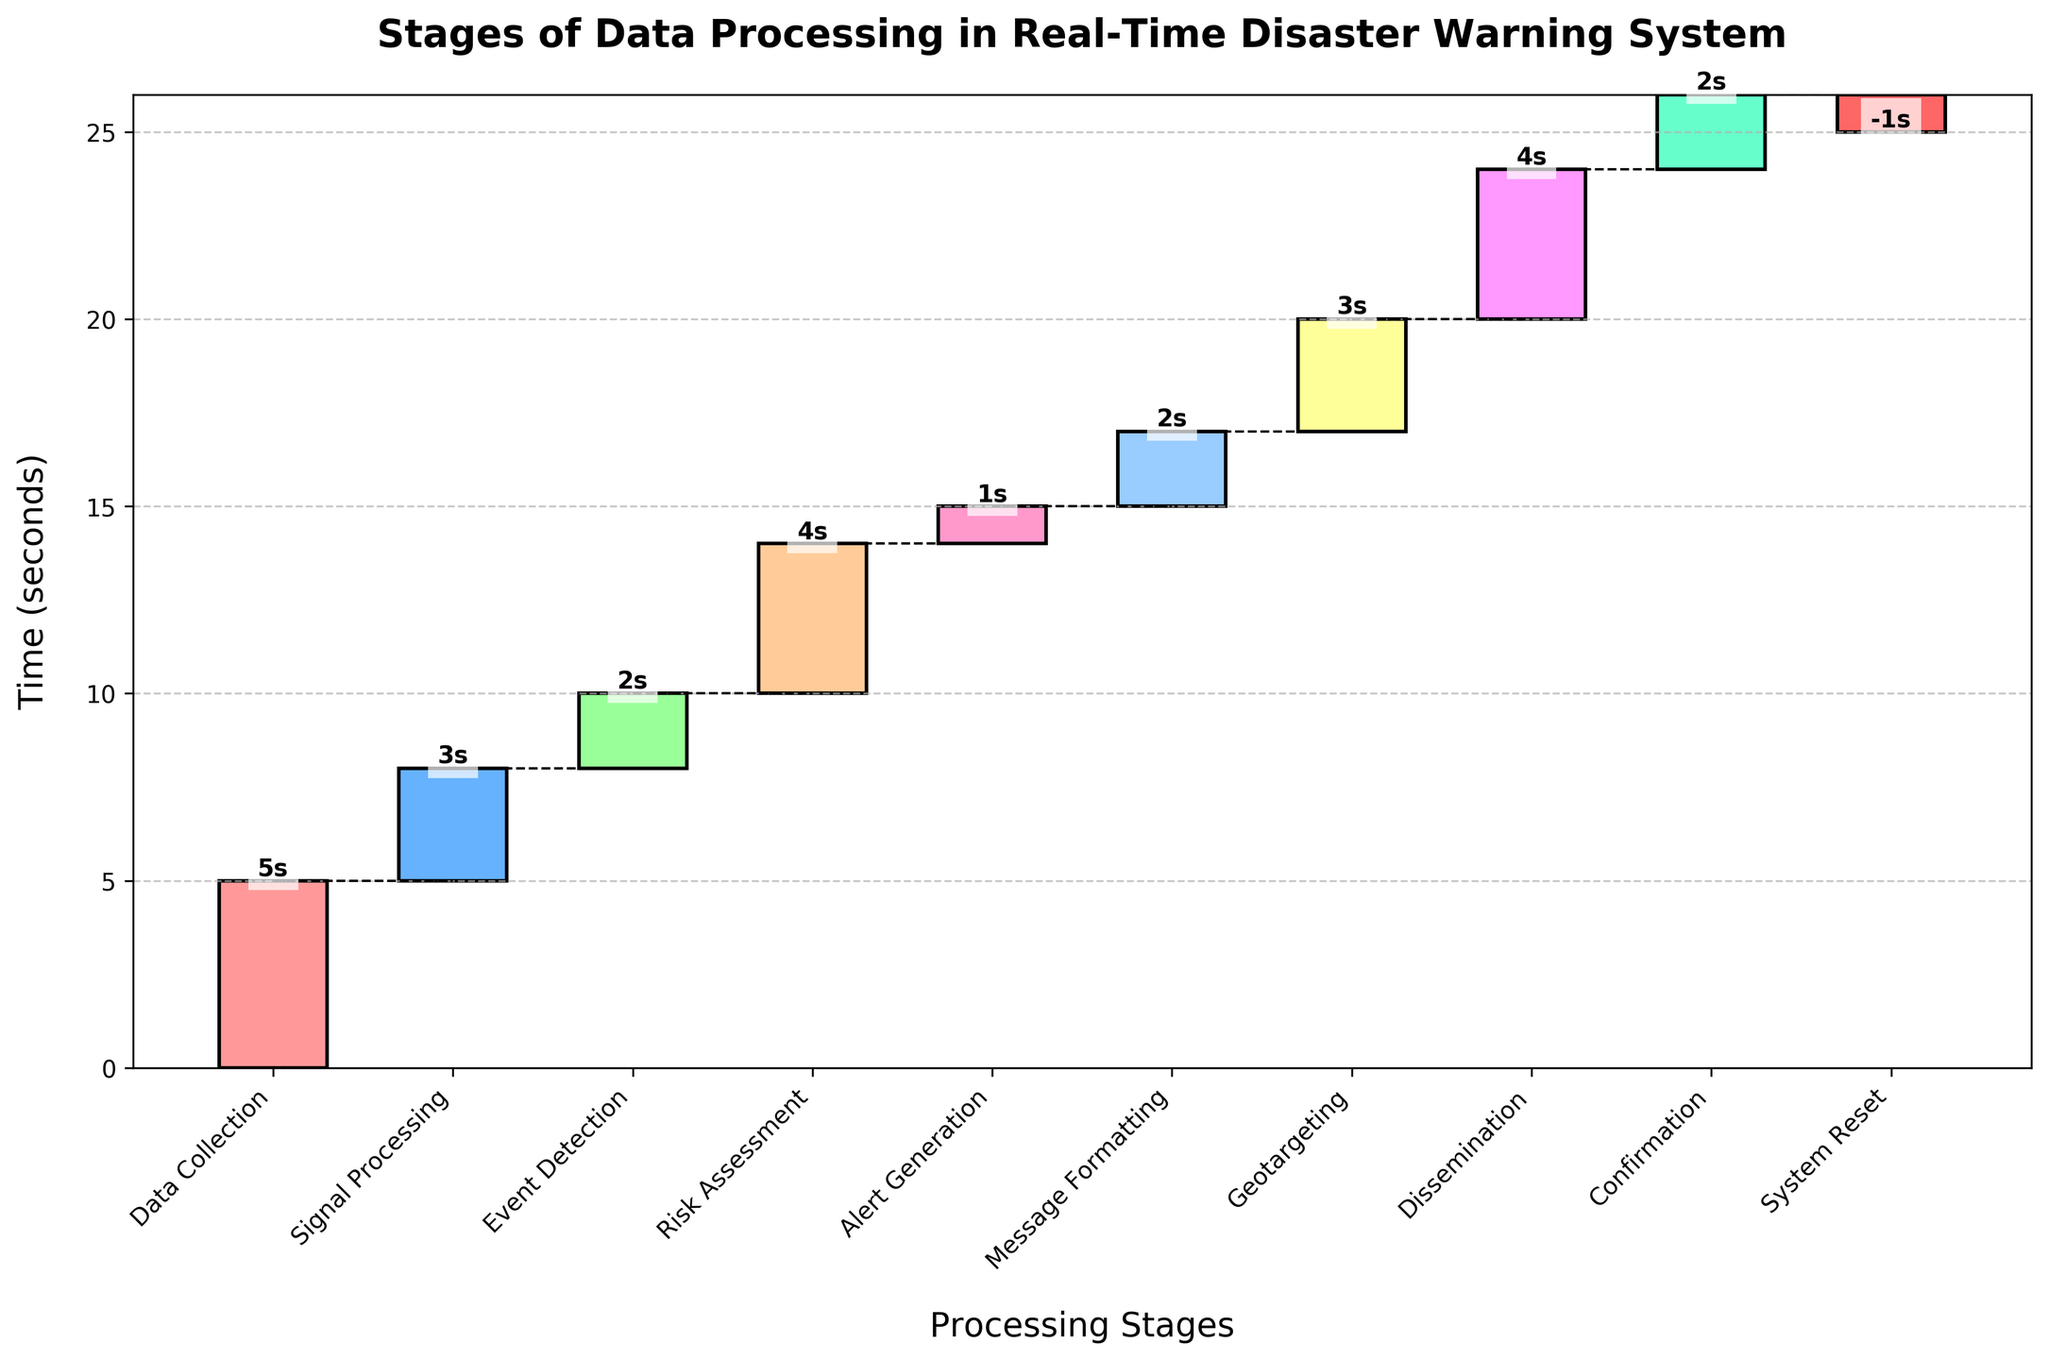what is the title of the chart? The title of the chart is usually displayed at the top of the figure. In this case, it is "Stages of Data Processing in Real-Time Disaster Warning System".
Answer: Stages of Data Processing in Real-Time Disaster Warning System How much time does the "Risk Assessment" stage take? The time for each stage is indicated by the height of the bars. The "Risk Assessment" stage takes 4 seconds, as shown on the bar labeled "Risk Assessment".
Answer: 4 seconds What is the total cumulative time after the "Geotargeting" stage? The cumulative time after each stage can be determined by summing the times up to that stage. For "Geotargeting", the stages are: 5 (Data Collection) + 3 (Signal Processing) + 2 (Event Detection) + 4 (Risk Assessment) + 1 (Alert Generation) + 2 (Message Formatting) + 3 (Geotargeting) = 20 seconds.
Answer: 20 seconds Which stage takes the least time? By comparing the heights of the bars, the "Alert Generation" stage takes the least time, which is 1 second.
Answer: Alert Generation What is the difference in time between the "Data Collection" and "Dissemination" stages? The time for "Data Collection" is 5 seconds, and the time for "Dissemination" is 4 seconds. The difference is 5 - 4 = 1 second.
Answer: 1 second What is the average time for the stages excluding the "System Reset"? Adding the times: 5 + 3 + 2 + 4 + 1 + 2 + 3 + 4 + 2 = 26 seconds. There are 9 stages. The average time is 26 / 9 ≈ 2.89 seconds.
Answer: 2.89 seconds What does the bar color change indicate? The different bar colors help to distinguish between different stages, but they do not indicate any specific variable changes in this context.
Answer: Different stages What would be the total time if "Signal Processing" took 5 seconds instead of 3? Recalculating with "Signal Processing" at 5 seconds: 5 + 5 + 2 + 4 + 1 + 2 + 3 + 4 + 2 - 1 = 27 seconds.
Answer: 27 seconds What visual element indicates the end of each stage? Dotted connecting lines between bars indicate the end of each stage, showing a separation from one stage to the next.
Answer: Dotted lines Would the total cumulative time increase or decrease if "System Reset" was 0 seconds instead of -1? If "System Reset" was 0 seconds, the cumulative sum would be higher by 1 second because we are adding less negative time.
Answer: Increase 